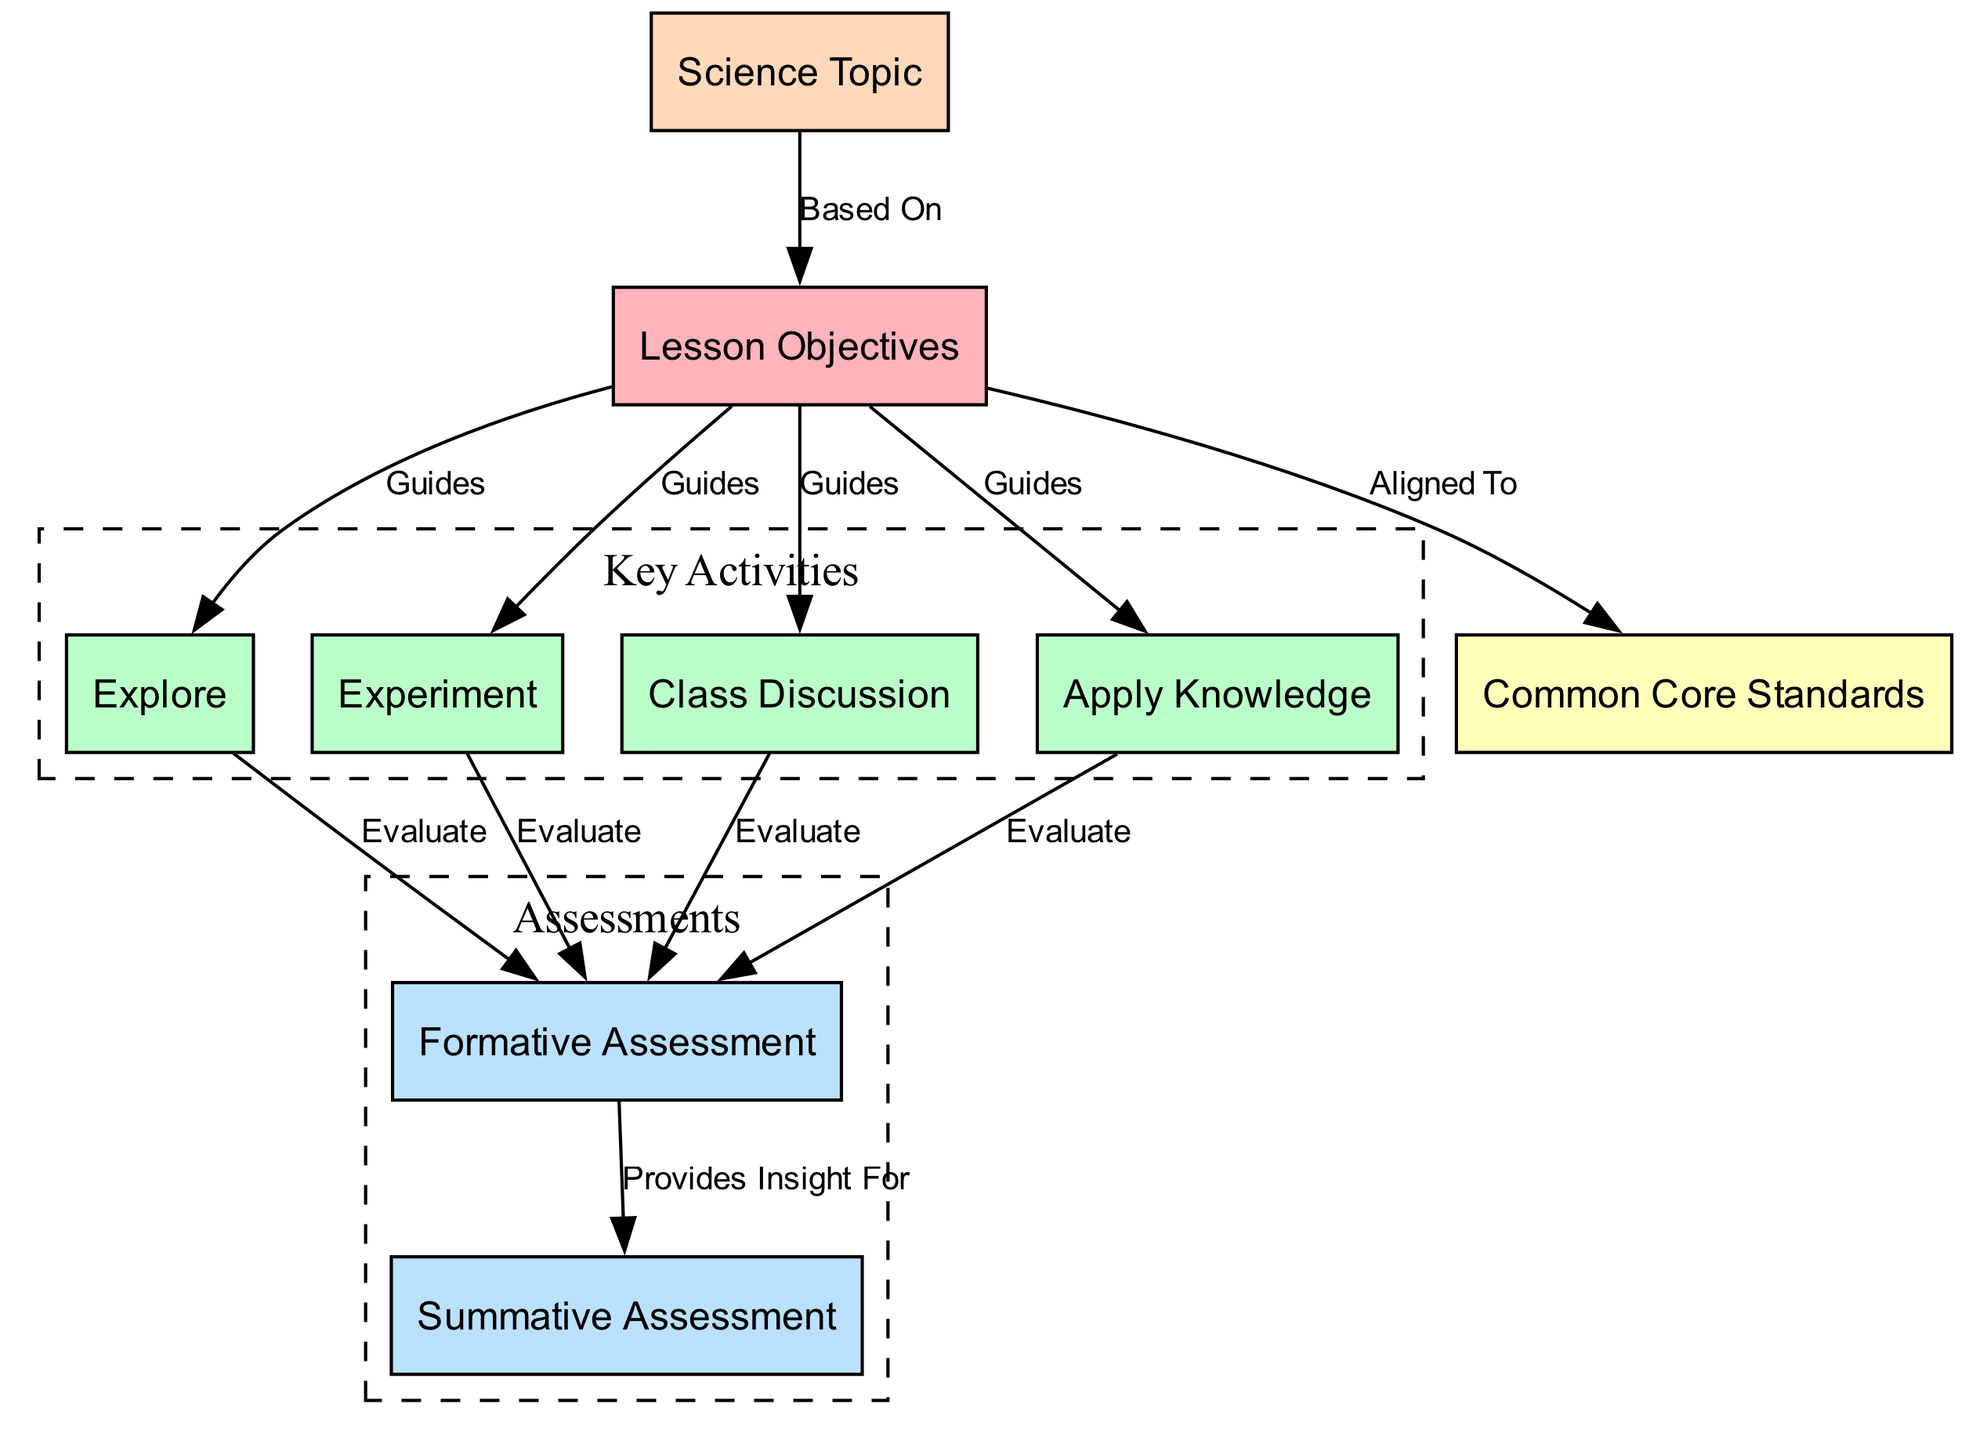What are the nodes in the diagram? The diagram contains several nodes, including "Lesson Objectives," "Explore," "Experiment," "Class Discussion," "Apply Knowledge," "Formative Assessment," "Summative Assessment," "Common Core Standards," and "Science Topic." By iterating through the "nodes" section of the data, we can list all the distinct entities represented.
Answer: Lesson Objectives, Explore, Experiment, Class Discussion, Apply Knowledge, Formative Assessment, Summative Assessment, Common Core Standards, Science Topic How many edges are there in total? The diagram has a total of 11 edges connecting various nodes. This can be determined by counting the entries in the "edges" section of the provided data.
Answer: 11 What guides the "Explore" activity? The "Explore" activity is guided by the "Lesson Objectives." In the diagram, this relationship is depicted as an edge from the "Lesson Objectives" node to the "Explore" node, highlighting that the activity is derived from these objectives.
Answer: Lesson Objectives Which assessments provide insight for summative assessment? The "Formative Assessment" provides insight for the "Summative Assessment." This can be determined by examining the edge connecting "Formative Assessment" to "Summative Assessment," indicating that insights from formative evaluations help in preparing for summative evaluations.
Answer: Formative Assessment What is aligned to the lesson objectives? The "Common Core Standards" are aligned to the "Lesson Objectives." This relationship is shown as an edge originating from the "Lesson Objectives" node to the "Common Core Standards" node, establishing the connection between objectives and standards.
Answer: Common Core Standards What activities evaluate knowledge? The activities "Explore," "Experiment," "Class Discussion," and "Apply Knowledge" evaluate knowledge as indicated by edges from each of these activities to the "Formative Assessment" node in the diagram. These connections illustrate that these activities feed into the evaluation process.
Answer: Explore, Experiment, Class Discussion, Apply Knowledge Which node is based on the science topic? The "Lesson Objectives" node is based on the "Science Topic." In the diagram, there is an edge that clearly indicates this direct relationship, showing that the objectives are grounded in the specific science topic being explored.
Answer: Lesson Objectives How many key activities are there? There are four key activities listed in the diagram: "Explore," "Experiment," "Class Discussion," and "Apply Knowledge." This count can be performed by reviewing the nodes designated as activities in the diagram.
Answer: 4 What is the purpose of formative assessment? The purpose of "Formative Assessment" is to evaluate the various activities ("Explore," "Experiment," "Class Discussion," and "Apply Knowledge") as shown by the edges connecting these activities to the formative assessment node. Each edge indicates that the formative assessment is used to gauge understanding following these activities.
Answer: Evaluate 